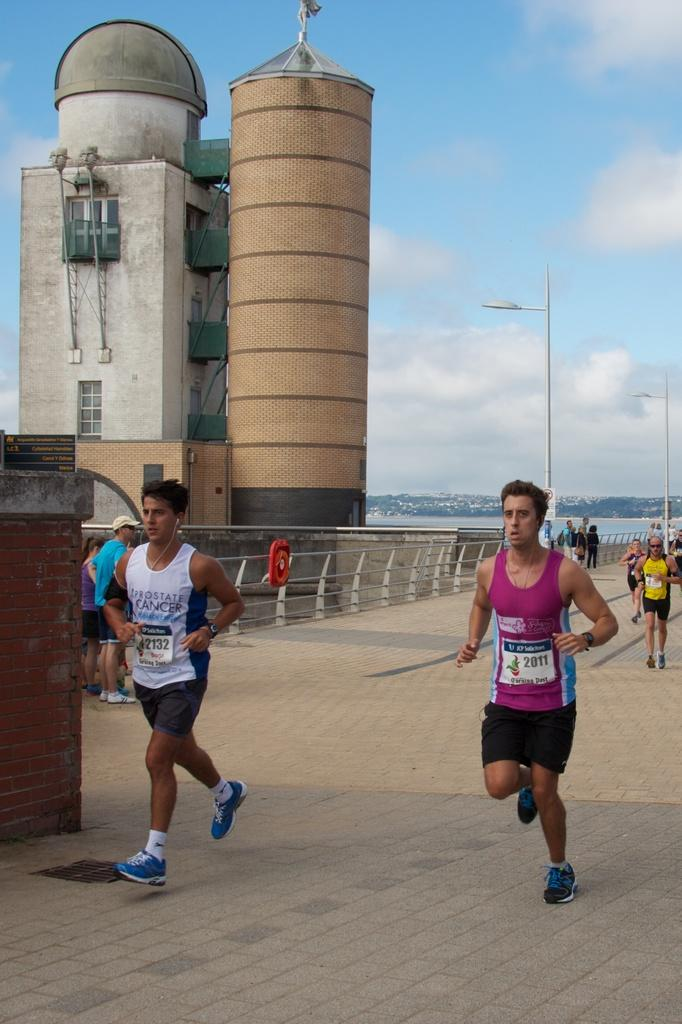What type of structures can be seen in the image? There are buildings in the image. What type of lighting is present in the image? There is a street lamp in the image. Are there any people visible in the image? Yes, there are people in the image. What type of barrier can be seen in the image? There is a fence in the image. What is visible in the background of the image? The sky is visible in the image, and clouds are present in the sky. What type of apples are growing in the garden in the image? There is no garden present in the image, and therefore no apples can be seen growing. How does the anger of the people in the image manifest itself? There is no indication of anger in the image; the people are not displaying any emotions. 